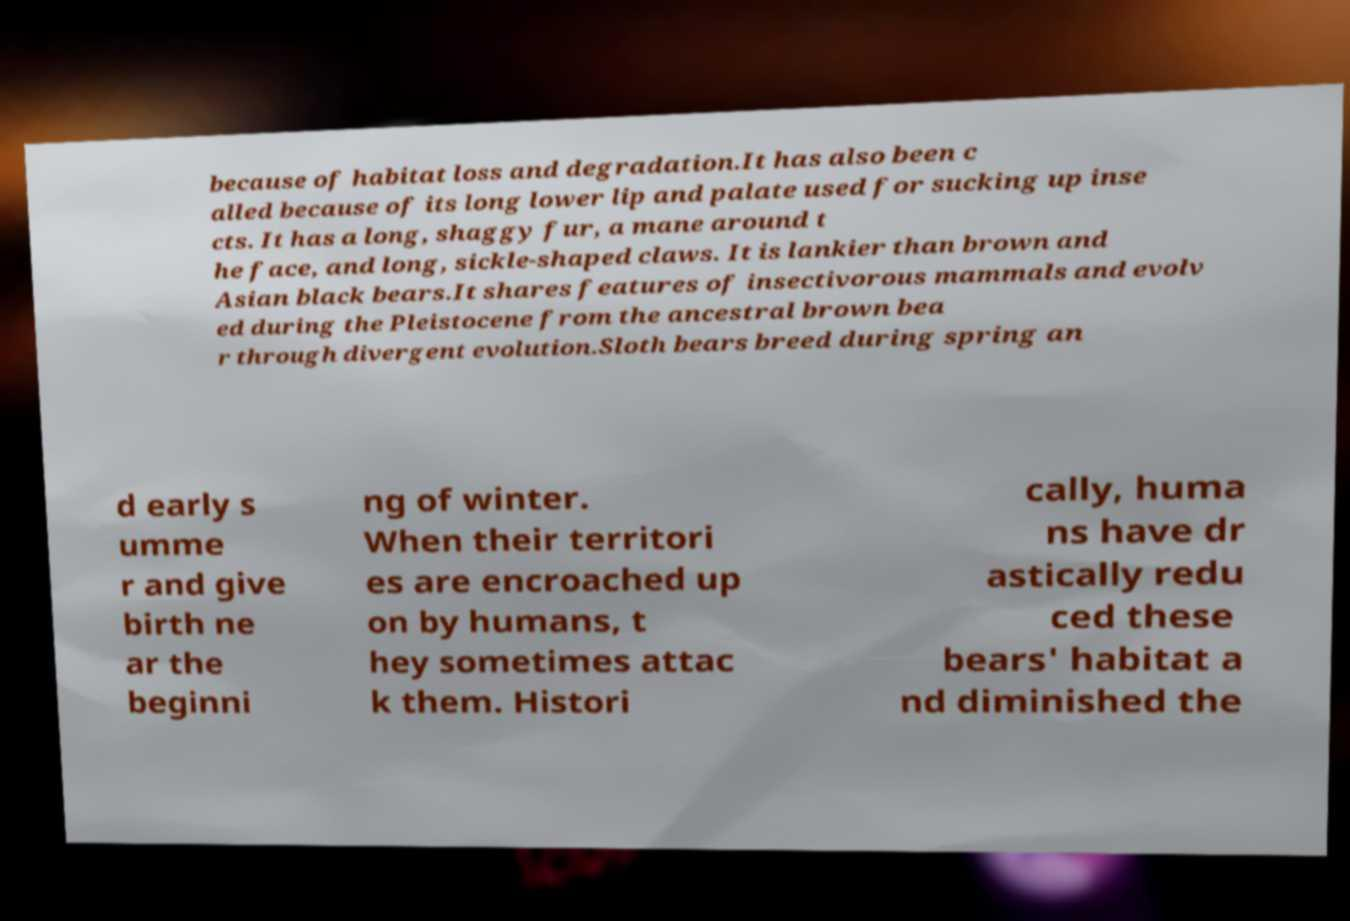For documentation purposes, I need the text within this image transcribed. Could you provide that? because of habitat loss and degradation.It has also been c alled because of its long lower lip and palate used for sucking up inse cts. It has a long, shaggy fur, a mane around t he face, and long, sickle-shaped claws. It is lankier than brown and Asian black bears.It shares features of insectivorous mammals and evolv ed during the Pleistocene from the ancestral brown bea r through divergent evolution.Sloth bears breed during spring an d early s umme r and give birth ne ar the beginni ng of winter. When their territori es are encroached up on by humans, t hey sometimes attac k them. Histori cally, huma ns have dr astically redu ced these bears' habitat a nd diminished the 